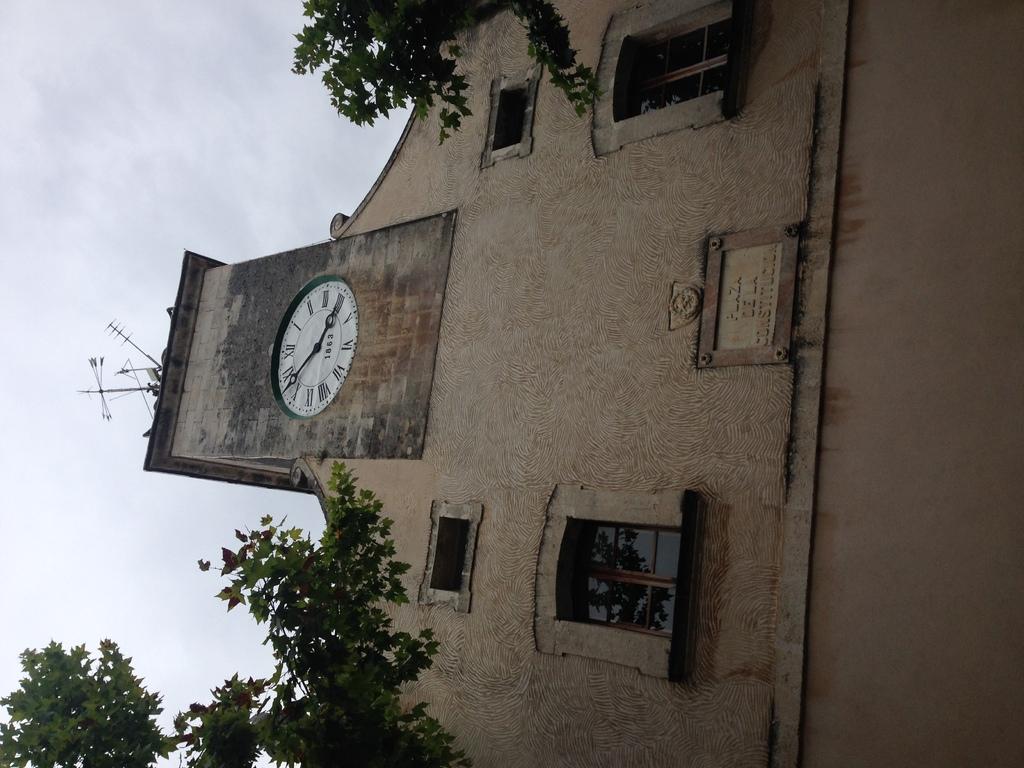What time is show on the clock?
Provide a short and direct response. 4:53. What is the first number on the clock?
Give a very brief answer. 1. 